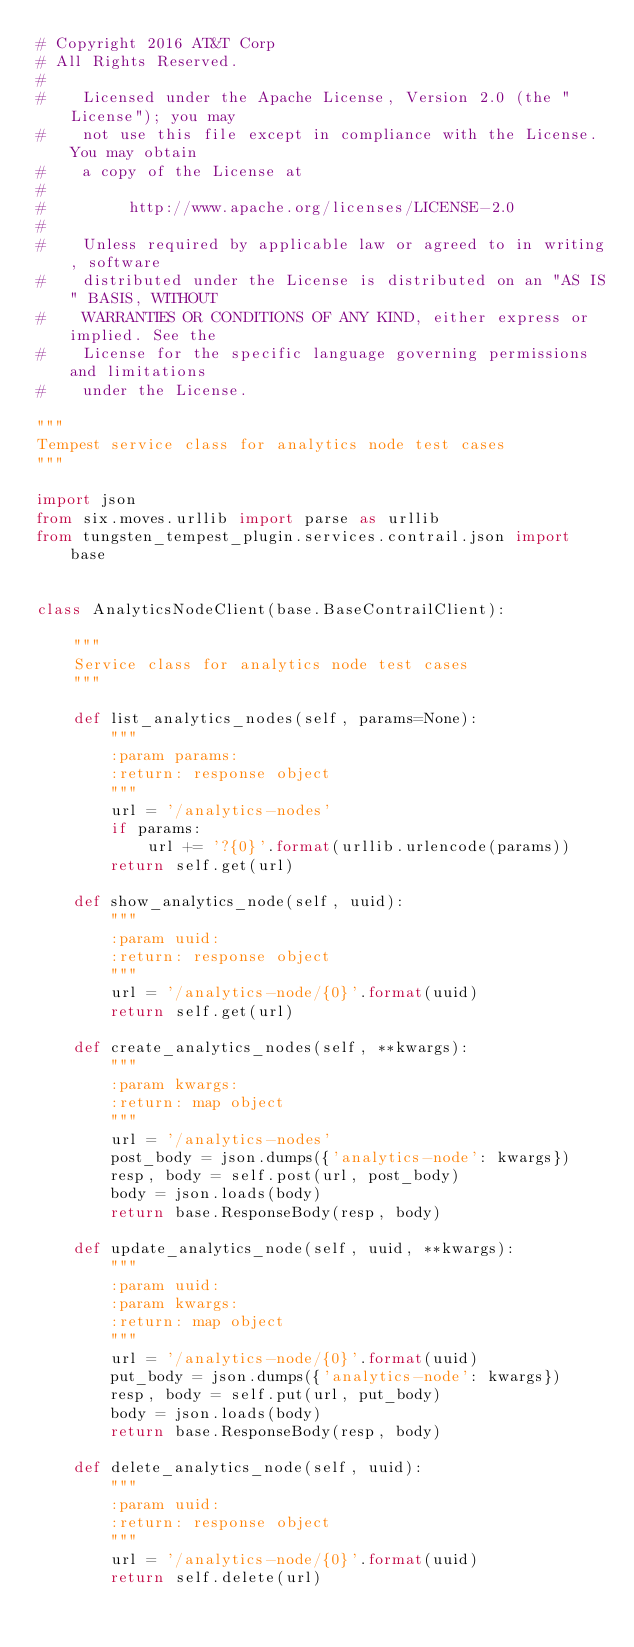Convert code to text. <code><loc_0><loc_0><loc_500><loc_500><_Python_># Copyright 2016 AT&T Corp
# All Rights Reserved.
#
#    Licensed under the Apache License, Version 2.0 (the "License"); you may
#    not use this file except in compliance with the License. You may obtain
#    a copy of the License at
#
#         http://www.apache.org/licenses/LICENSE-2.0
#
#    Unless required by applicable law or agreed to in writing, software
#    distributed under the License is distributed on an "AS IS" BASIS, WITHOUT
#    WARRANTIES OR CONDITIONS OF ANY KIND, either express or implied. See the
#    License for the specific language governing permissions and limitations
#    under the License.

"""
Tempest service class for analytics node test cases
"""

import json
from six.moves.urllib import parse as urllib
from tungsten_tempest_plugin.services.contrail.json import base


class AnalyticsNodeClient(base.BaseContrailClient):

    """
    Service class for analytics node test cases
    """

    def list_analytics_nodes(self, params=None):
        """
        :param params:
        :return: response object
        """
        url = '/analytics-nodes'
        if params:
            url += '?{0}'.format(urllib.urlencode(params))
        return self.get(url)

    def show_analytics_node(self, uuid):
        """
        :param uuid:
        :return: response object
        """
        url = '/analytics-node/{0}'.format(uuid)
        return self.get(url)

    def create_analytics_nodes(self, **kwargs):
        """
        :param kwargs:
        :return: map object
        """
        url = '/analytics-nodes'
        post_body = json.dumps({'analytics-node': kwargs})
        resp, body = self.post(url, post_body)
        body = json.loads(body)
        return base.ResponseBody(resp, body)

    def update_analytics_node(self, uuid, **kwargs):
        """
        :param uuid:
        :param kwargs:
        :return: map object
        """
        url = '/analytics-node/{0}'.format(uuid)
        put_body = json.dumps({'analytics-node': kwargs})
        resp, body = self.put(url, put_body)
        body = json.loads(body)
        return base.ResponseBody(resp, body)

    def delete_analytics_node(self, uuid):
        """
        :param uuid:
        :return: response object
        """
        url = '/analytics-node/{0}'.format(uuid)
        return self.delete(url)
</code> 